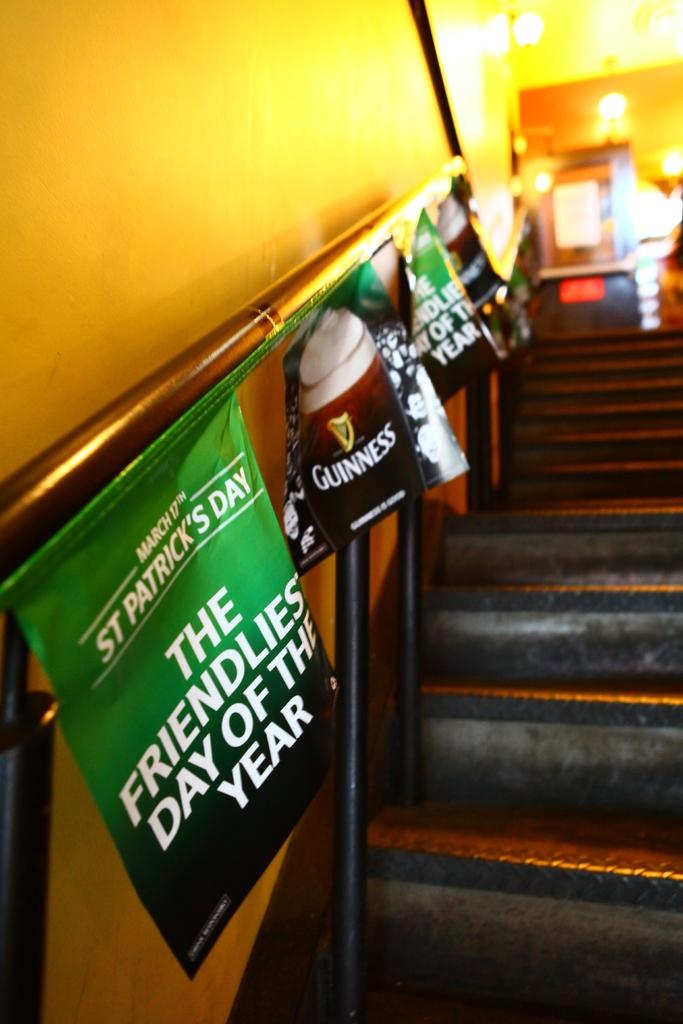<image>
Share a concise interpretation of the image provided. A staircase with banners for St. Patrick's Day and Guinness is shown. 